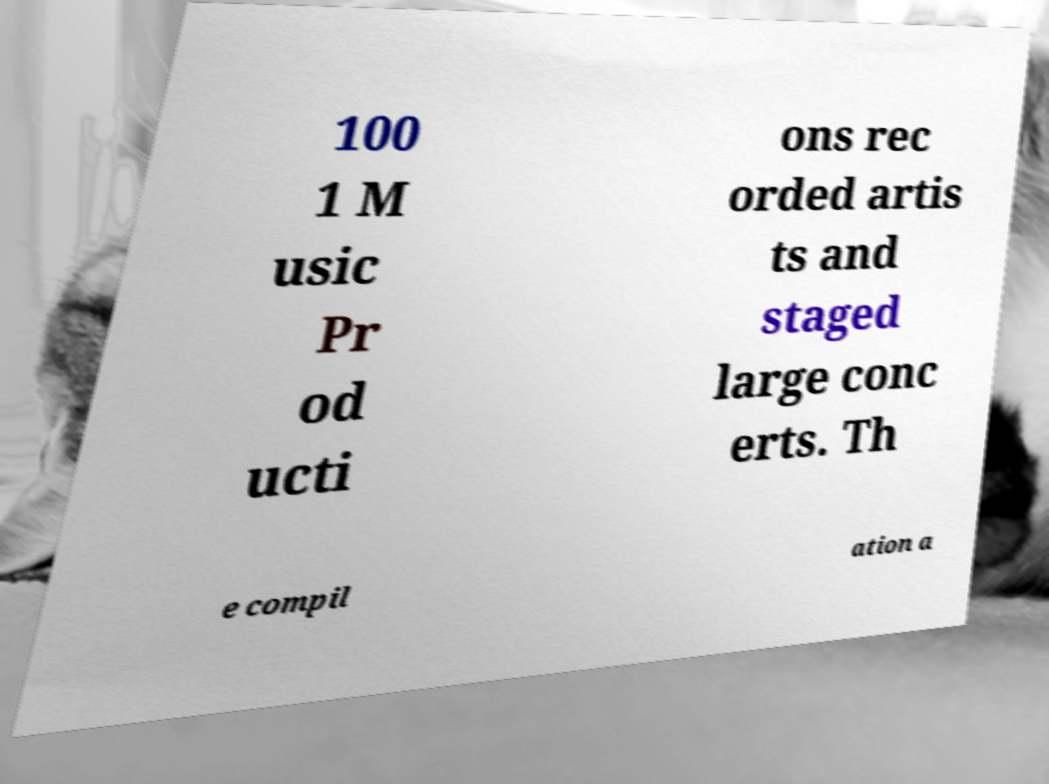Please identify and transcribe the text found in this image. 100 1 M usic Pr od ucti ons rec orded artis ts and staged large conc erts. Th e compil ation a 